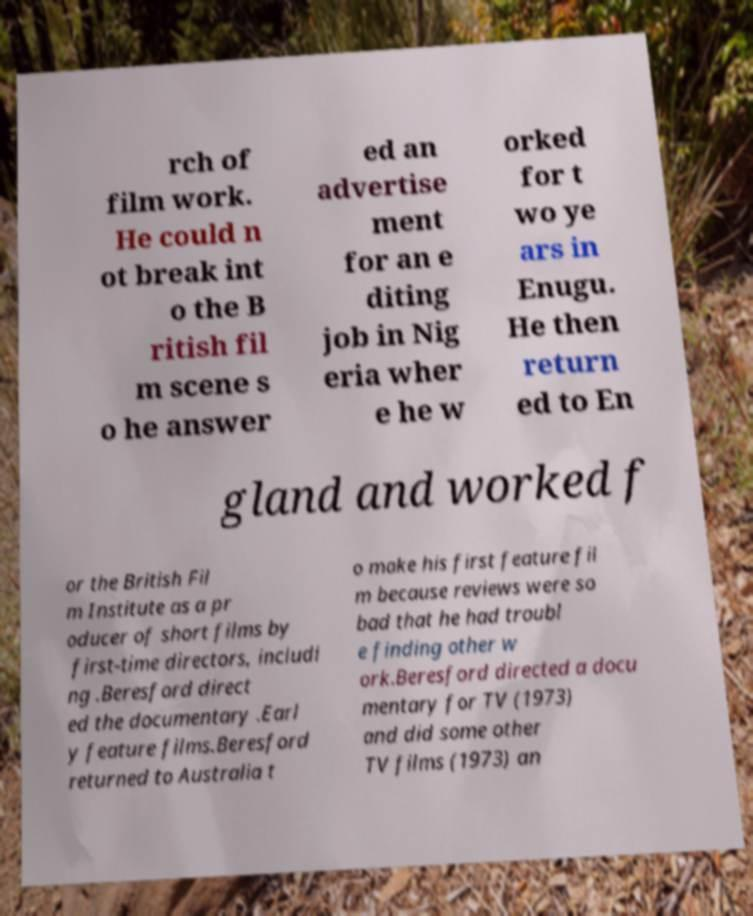Can you accurately transcribe the text from the provided image for me? rch of film work. He could n ot break int o the B ritish fil m scene s o he answer ed an advertise ment for an e diting job in Nig eria wher e he w orked for t wo ye ars in Enugu. He then return ed to En gland and worked f or the British Fil m Institute as a pr oducer of short films by first-time directors, includi ng .Beresford direct ed the documentary .Earl y feature films.Beresford returned to Australia t o make his first feature fil m because reviews were so bad that he had troubl e finding other w ork.Beresford directed a docu mentary for TV (1973) and did some other TV films (1973) an 